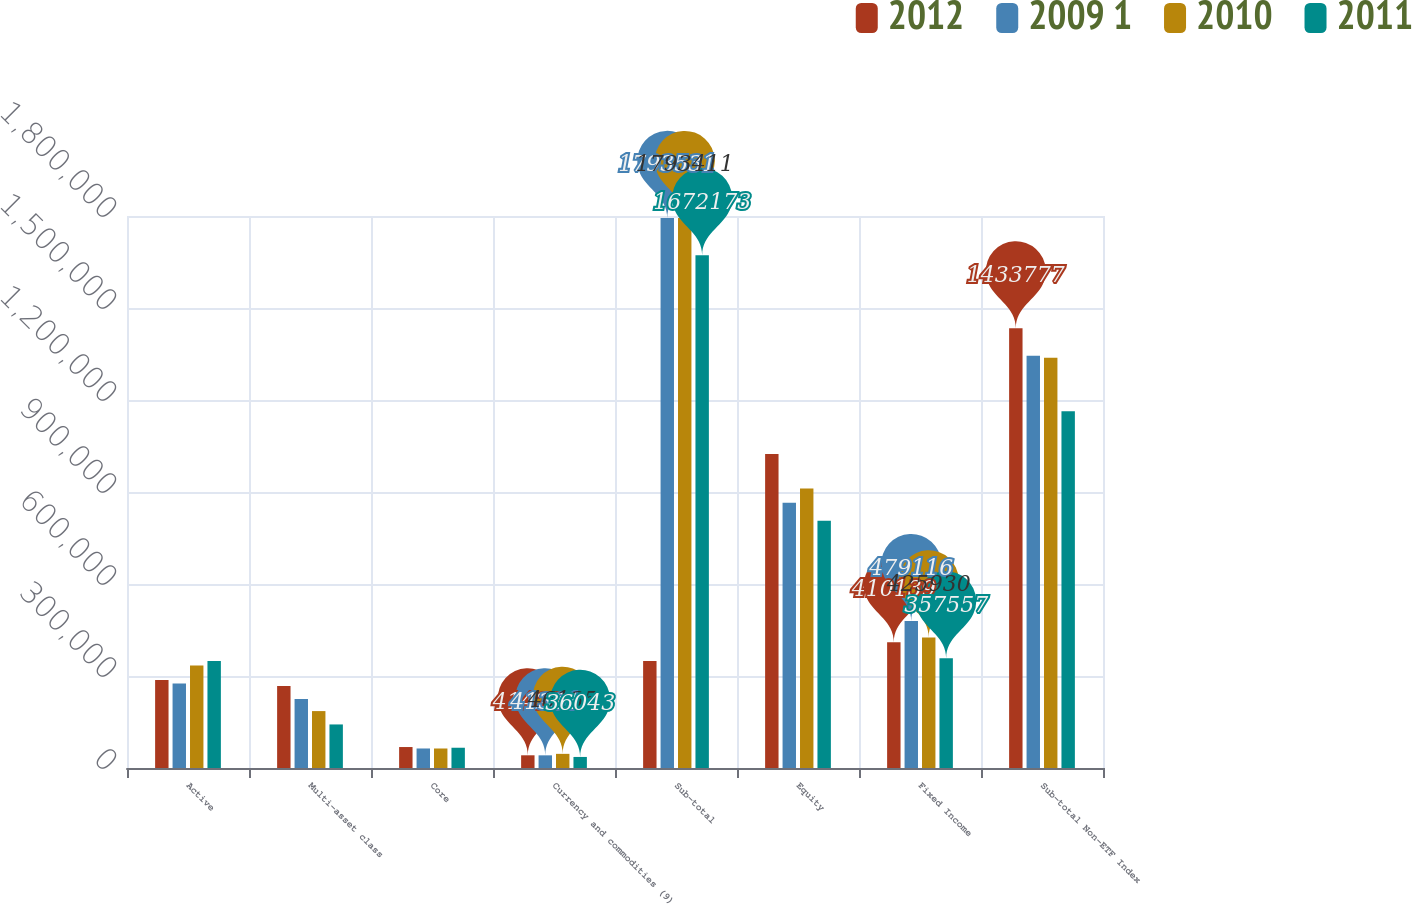Convert chart. <chart><loc_0><loc_0><loc_500><loc_500><stacked_bar_chart><ecel><fcel>Active<fcel>Multi-asset class<fcel>Core<fcel>Currency and commodities (9)<fcel>Sub-total<fcel>Equity<fcel>Fixed Income<fcel>Sub-total Non-ETF Index<nl><fcel>2012<fcel>287215<fcel>267748<fcel>68367<fcel>41428<fcel>348574<fcel>1.02364e+06<fcel>410139<fcel>1.43378e+06<nl><fcel>2009 1<fcel>275156<fcel>225170<fcel>63647<fcel>41301<fcel>1.79353e+06<fcel>865299<fcel>479116<fcel>1.34442e+06<nl><fcel>2010<fcel>334532<fcel>185587<fcel>63603<fcel>46135<fcel>1.79341e+06<fcel>911775<fcel>425930<fcel>1.3377e+06<nl><fcel>2011<fcel>348574<fcel>142029<fcel>66058<fcel>36043<fcel>1.67217e+06<fcel>806082<fcel>357557<fcel>1.16364e+06<nl></chart> 